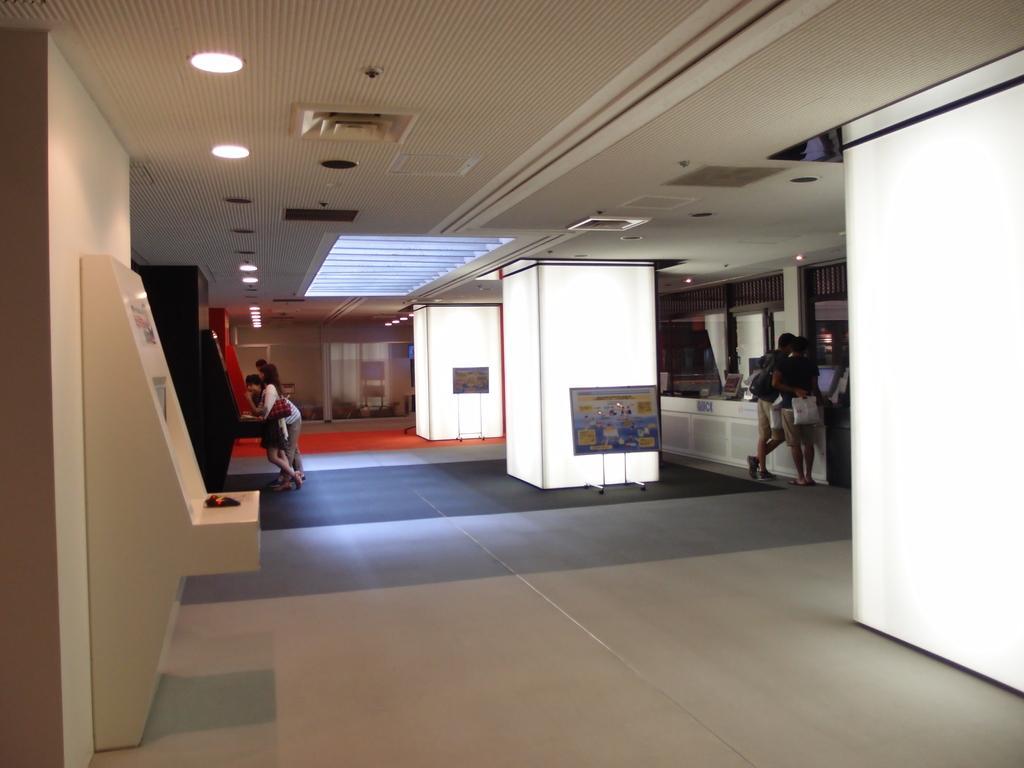Can you describe this image briefly? This image is clicked inside a room. There are lights at the top. There are some persons standing in the middle. 